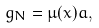Convert formula to latex. <formula><loc_0><loc_0><loc_500><loc_500>g _ { N } = \mu ( x ) a ,</formula> 